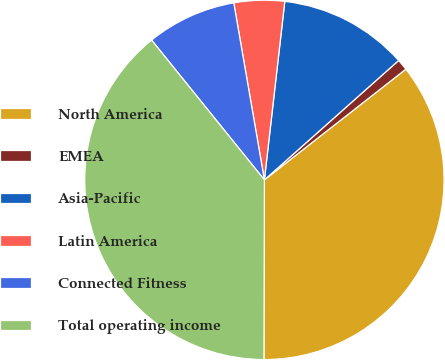Convert chart to OTSL. <chart><loc_0><loc_0><loc_500><loc_500><pie_chart><fcel>North America<fcel>EMEA<fcel>Asia-Pacific<fcel>Latin America<fcel>Connected Fitness<fcel>Total operating income<nl><fcel>35.62%<fcel>1.0%<fcel>11.62%<fcel>4.54%<fcel>8.08%<fcel>39.16%<nl></chart> 